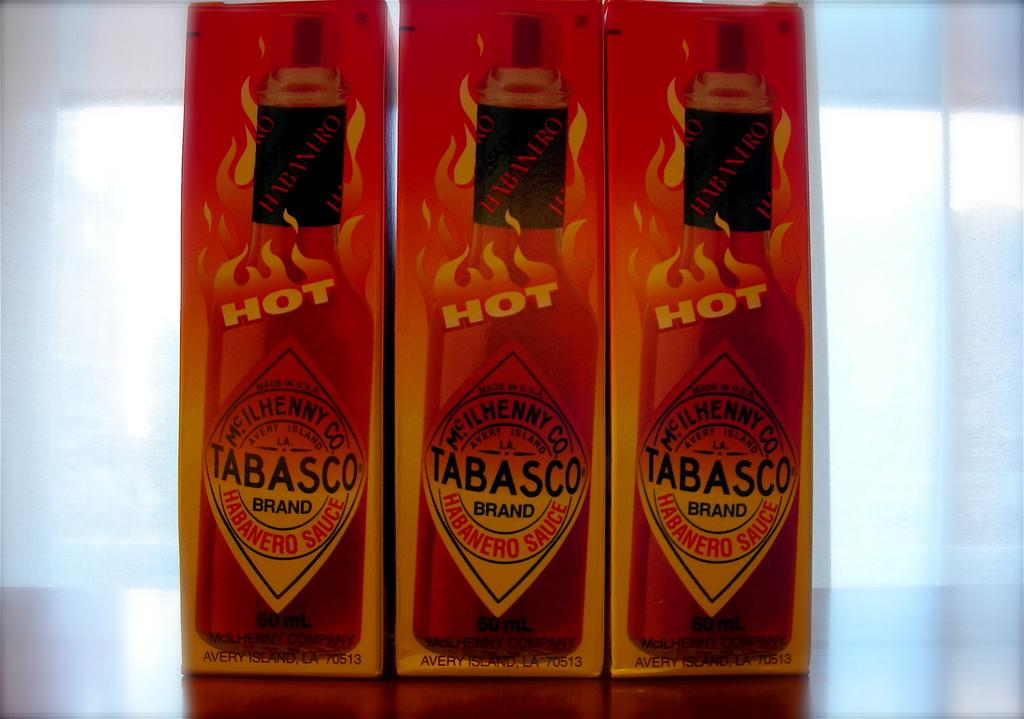<image>
Provide a brief description of the given image. Three boxoes of Tabasco hot sauce next to one another. 